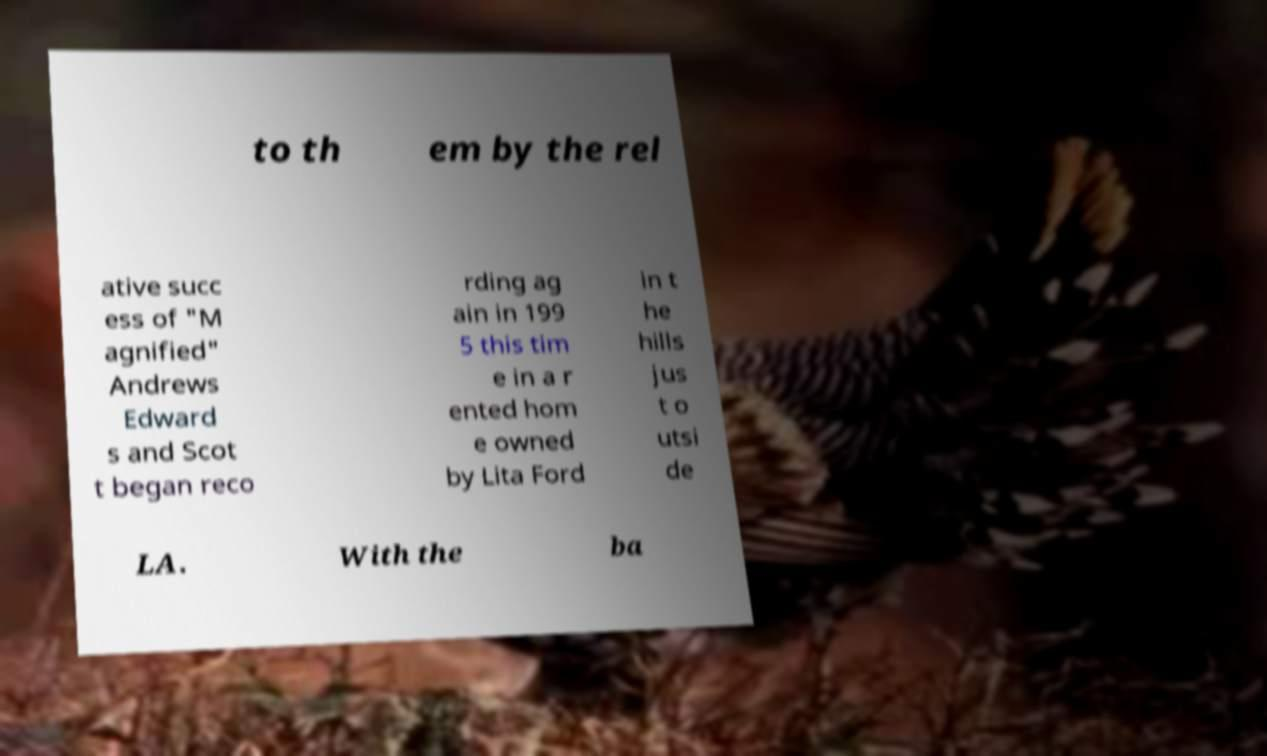I need the written content from this picture converted into text. Can you do that? to th em by the rel ative succ ess of "M agnified" Andrews Edward s and Scot t began reco rding ag ain in 199 5 this tim e in a r ented hom e owned by Lita Ford in t he hills jus t o utsi de LA. With the ba 